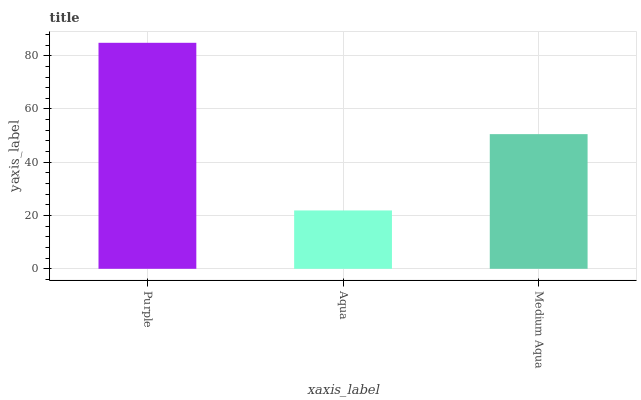Is Aqua the minimum?
Answer yes or no. Yes. Is Purple the maximum?
Answer yes or no. Yes. Is Medium Aqua the minimum?
Answer yes or no. No. Is Medium Aqua the maximum?
Answer yes or no. No. Is Medium Aqua greater than Aqua?
Answer yes or no. Yes. Is Aqua less than Medium Aqua?
Answer yes or no. Yes. Is Aqua greater than Medium Aqua?
Answer yes or no. No. Is Medium Aqua less than Aqua?
Answer yes or no. No. Is Medium Aqua the high median?
Answer yes or no. Yes. Is Medium Aqua the low median?
Answer yes or no. Yes. Is Purple the high median?
Answer yes or no. No. Is Purple the low median?
Answer yes or no. No. 